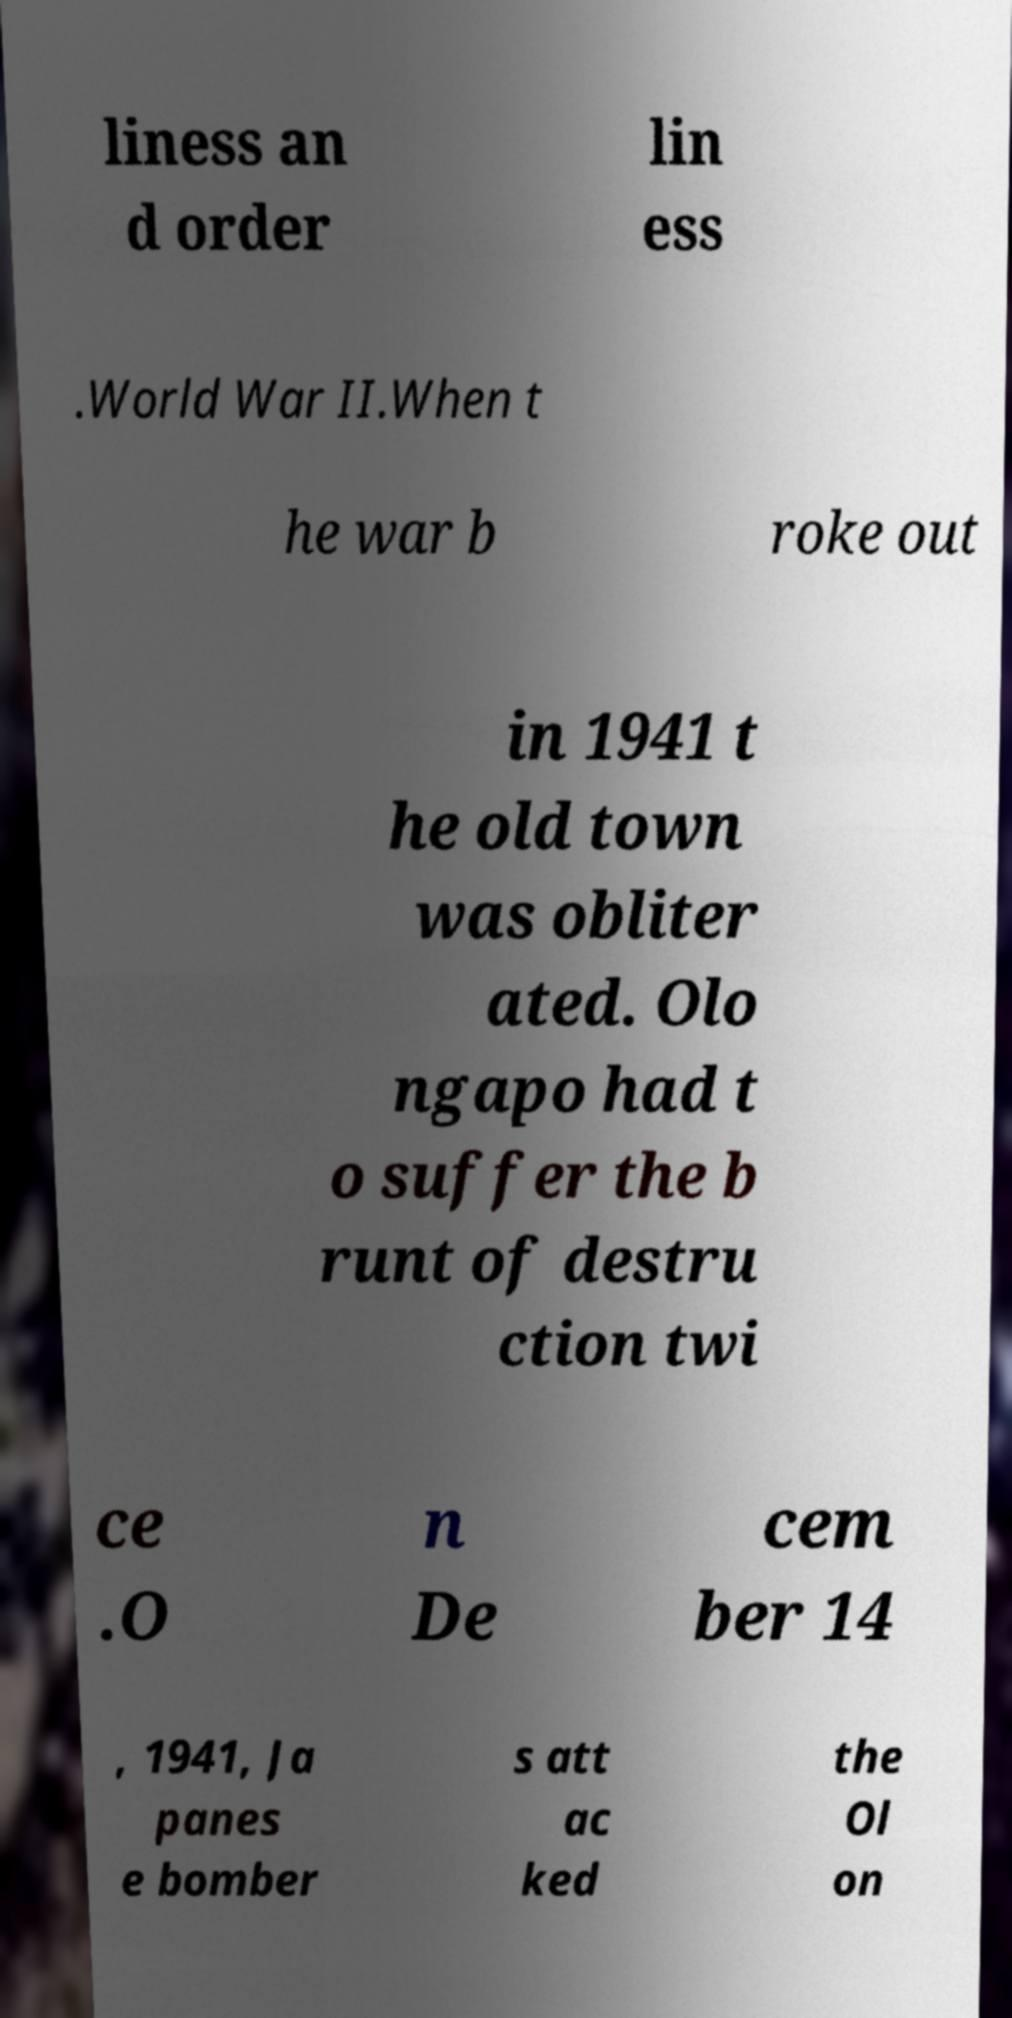Can you accurately transcribe the text from the provided image for me? liness an d order lin ess .World War II.When t he war b roke out in 1941 t he old town was obliter ated. Olo ngapo had t o suffer the b runt of destru ction twi ce .O n De cem ber 14 , 1941, Ja panes e bomber s att ac ked the Ol on 